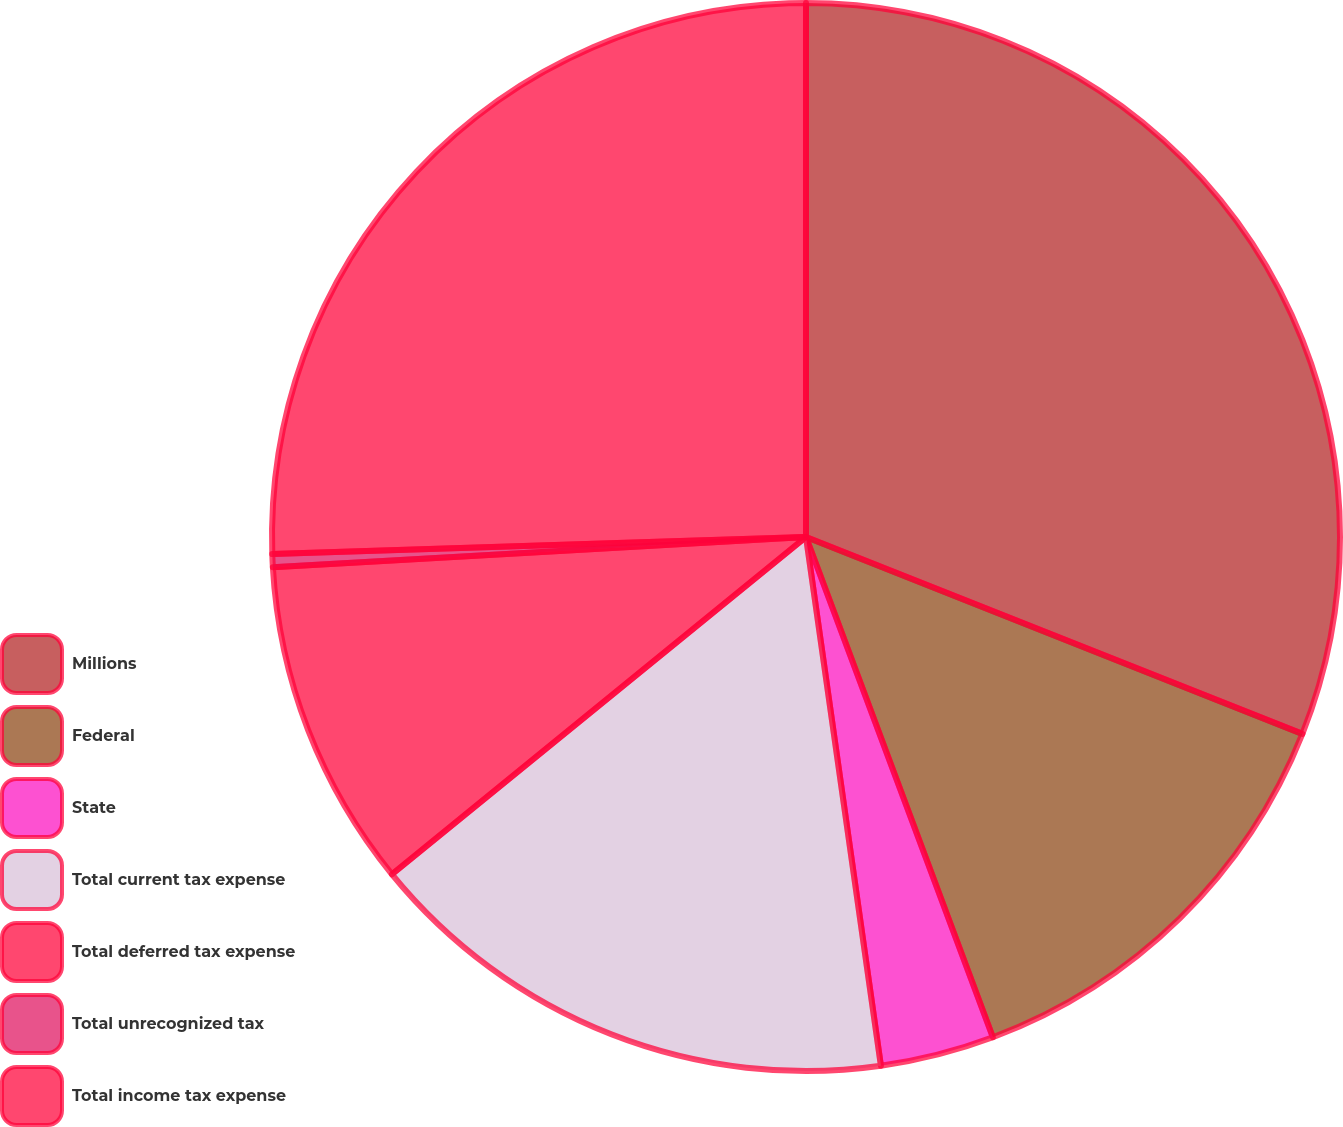Convert chart to OTSL. <chart><loc_0><loc_0><loc_500><loc_500><pie_chart><fcel>Millions<fcel>Federal<fcel>State<fcel>Total current tax expense<fcel>Total deferred tax expense<fcel>Total unrecognized tax<fcel>Total income tax expense<nl><fcel>31.01%<fcel>13.3%<fcel>3.45%<fcel>16.36%<fcel>9.98%<fcel>0.39%<fcel>25.51%<nl></chart> 